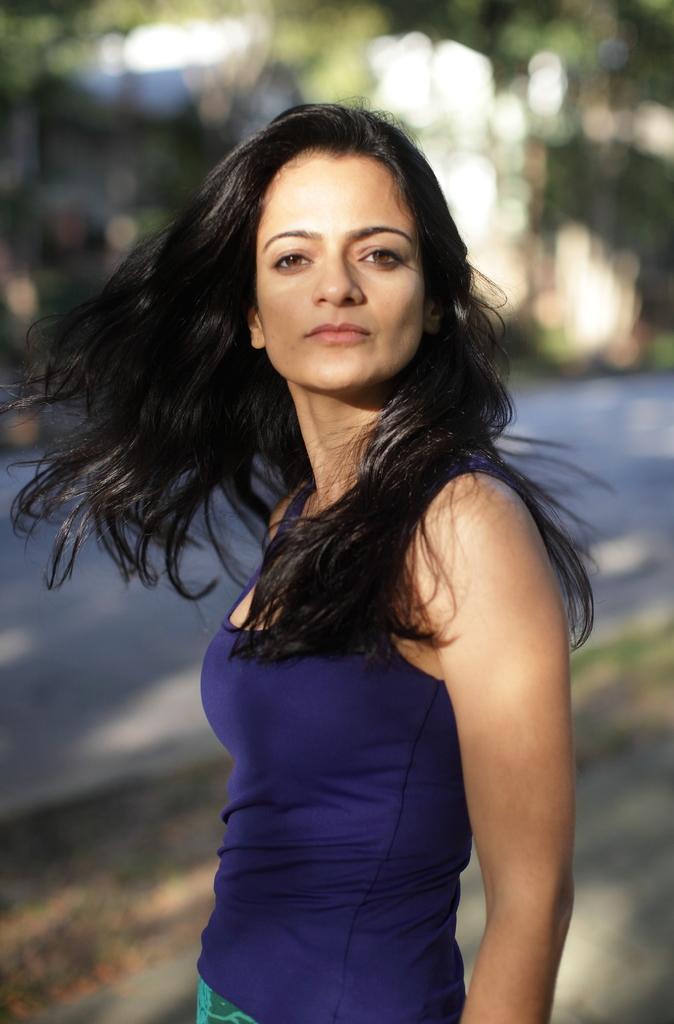In one or two sentences, can you explain what this image depicts? In this picture I can see there is a woman standing and she is wearing a blue shirt and there is a road in the backdrop and there are few trees. The backdrop is blurred. 